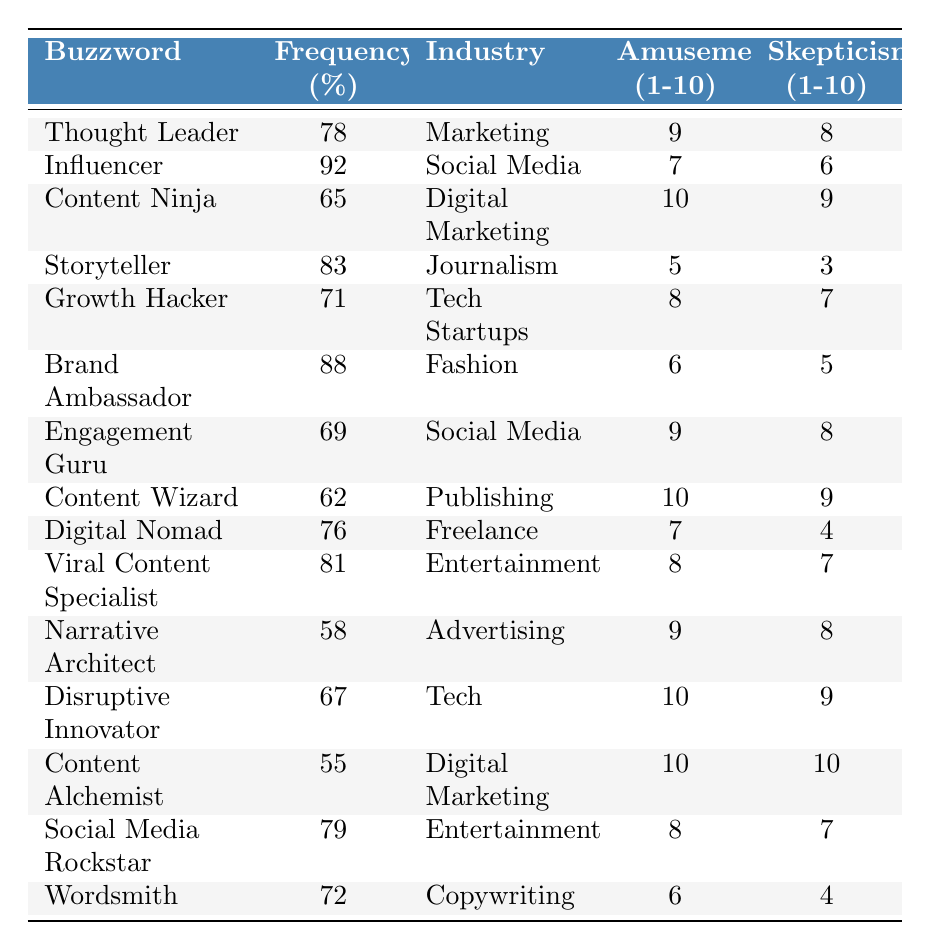What is the buzzword with the highest frequency percentage? The buzzword with the highest frequency percentage is "Influencer," which has a frequency of 92%.
Answer: Influencer Which industry is "Content Ninja" associated with? "Content Ninja" is associated with the Digital Marketing industry.
Answer: Digital Marketing What is the lowest skepticism level among the buzzwords listed? The lowest skepticism level is 3, which corresponds to the buzzword "Storyteller."
Answer: 3 How many buzzwords have an amusement level of 10? There are three buzzwords with an amusement level of 10: "Content Ninja," "Content Wizard," and "Content Alchemist."
Answer: 3 Is "Growth Hacker" more likely to be associated with Tech Startups than "Thought Leader"? Yes, "Growth Hacker" is specifically associated with Tech Startups, while "Thought Leader" is associated with Marketing.
Answer: Yes What is the average frequency percentage of the buzzwords in the table? The sum of frequency percentages is 1,213% (adding all frequencies), and there are 15 buzzwords, so the average is 1,213% / 15 = 80.87%.
Answer: 80.87% Which buzzword has the highest amusement level but also a high skepticism level? "Content Ninja" has the highest amusement level of 10 and a skepticism level of 9, which is high.
Answer: Content Ninja Which industry has the buzzword "Narrative Architect"? "Narrative Architect" is associated with the Advertising industry.
Answer: Advertising Are there any buzzwords in the Fashion industry with an amusement level of 7 or higher? No, the only buzzword in the Fashion industry is "Brand Ambassador," which has an amusement level of 6, which is less than 7.
Answer: No What are the differences in amusement levels between the highest and lowest buzzwords? The highest amusement level is 10 (for "Content Ninja," "Content Wizard," and "Content Alchemist"), while the lowest is 5 (for "Storyteller"). The difference is 10 - 5 = 5.
Answer: 5 